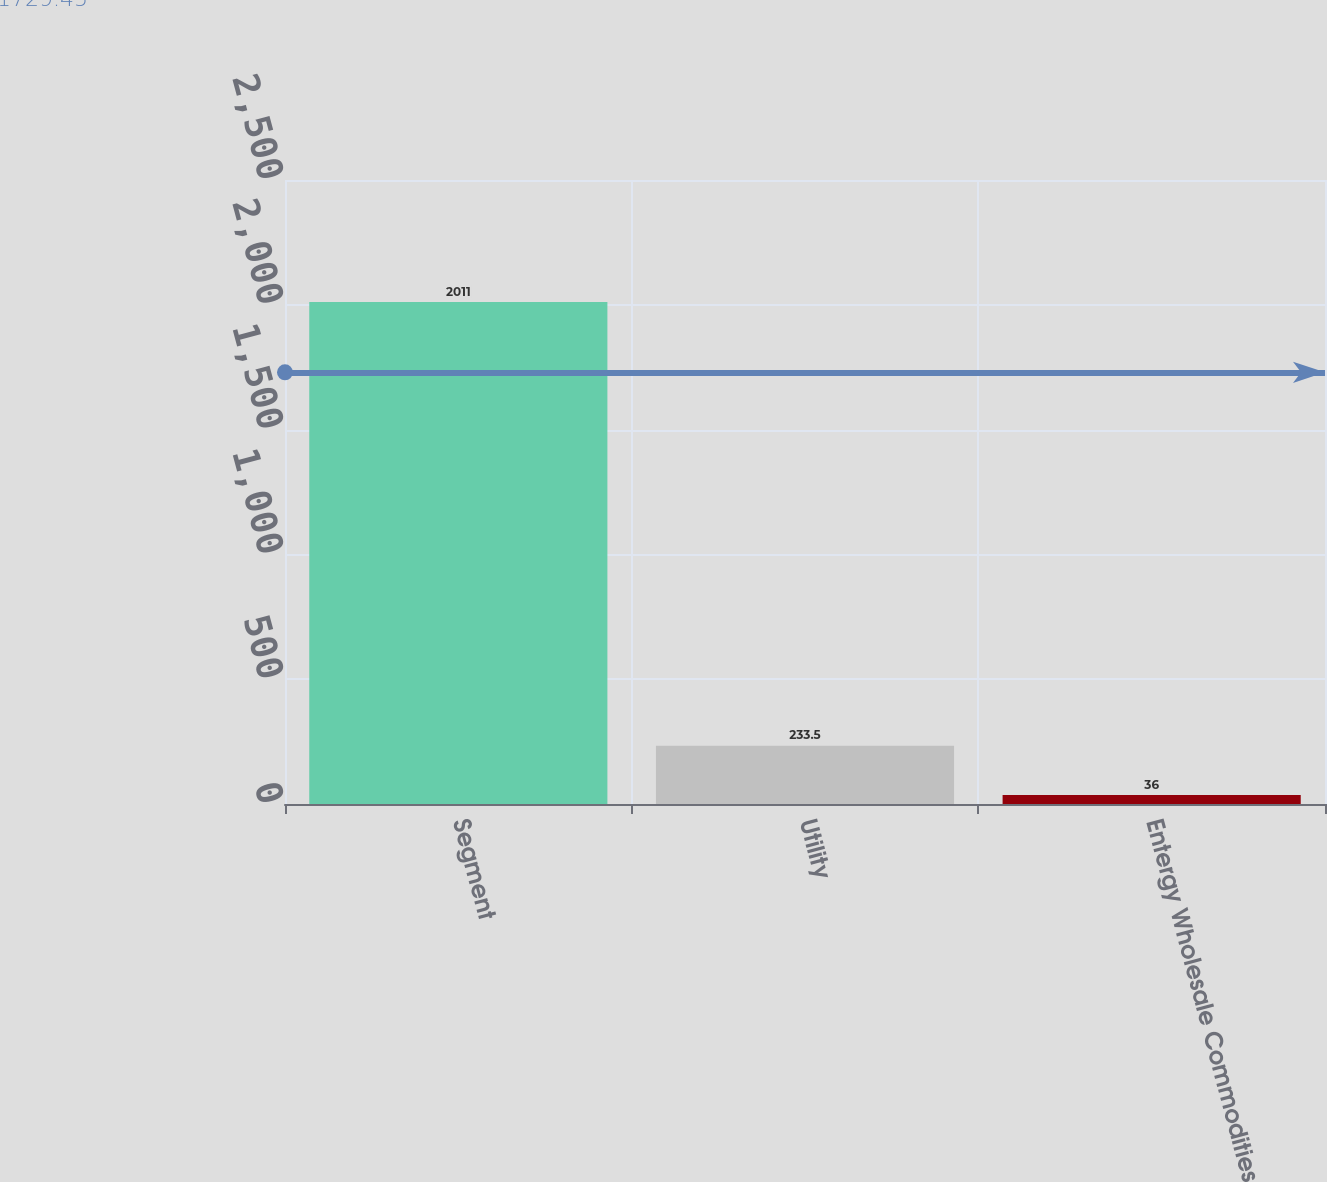Convert chart to OTSL. <chart><loc_0><loc_0><loc_500><loc_500><bar_chart><fcel>Segment<fcel>Utility<fcel>Entergy Wholesale Commodities<nl><fcel>2011<fcel>233.5<fcel>36<nl></chart> 